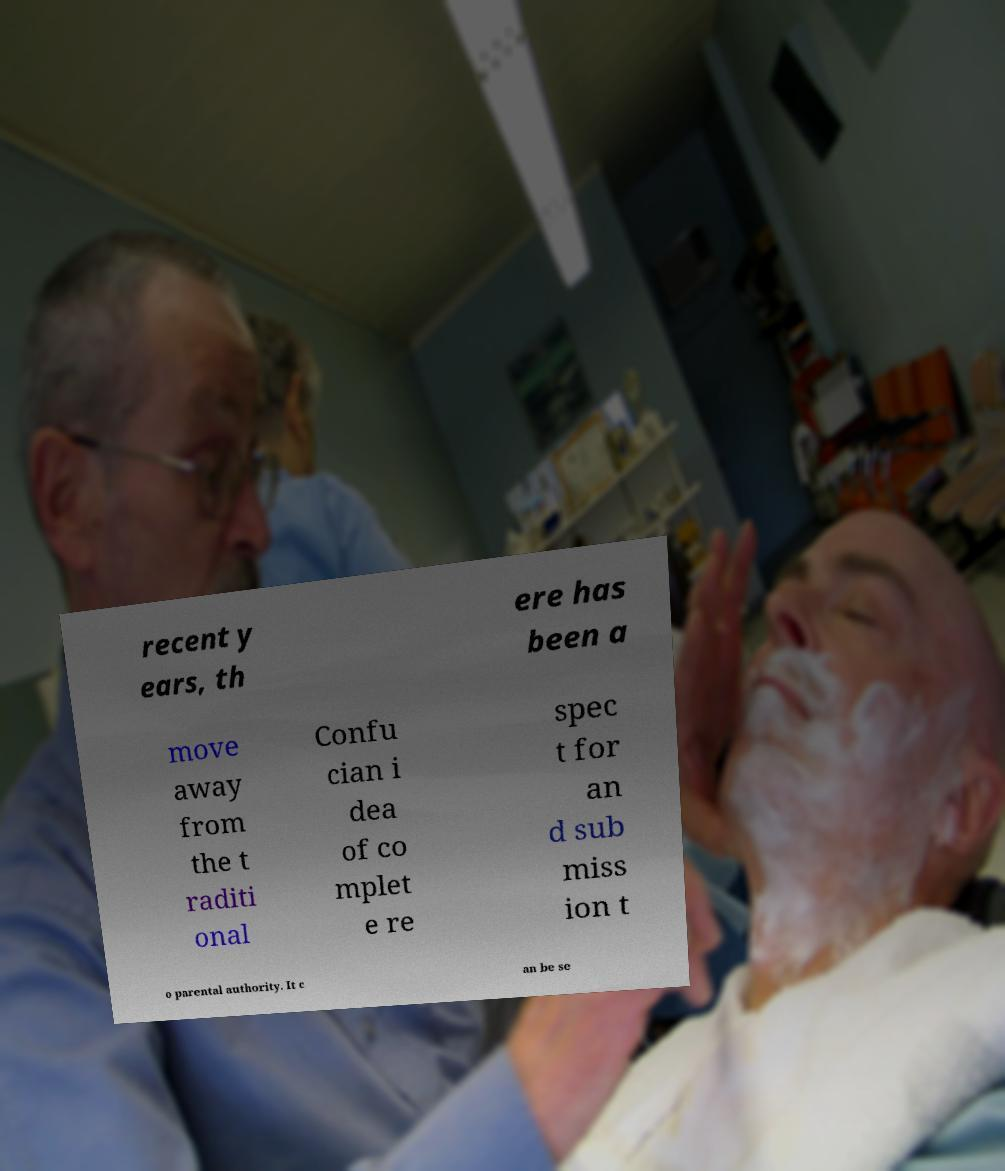Can you read and provide the text displayed in the image?This photo seems to have some interesting text. Can you extract and type it out for me? recent y ears, th ere has been a move away from the t raditi onal Confu cian i dea of co mplet e re spec t for an d sub miss ion t o parental authority. It c an be se 